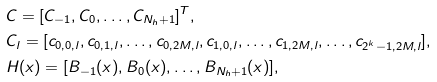<formula> <loc_0><loc_0><loc_500><loc_500>& C = [ C _ { - 1 } , C _ { 0 } , \dots , C _ { N _ { h } + 1 } ] ^ { T } , \\ & C _ { l } = [ c _ { 0 , 0 , l } , c _ { 0 , 1 , l } , \dots , c _ { 0 , 2 M , l } , c _ { 1 , 0 , l } , \dots , c _ { 1 , 2 M , l } , \dots , c _ { 2 ^ { k } - 1 , 2 M , l } ] , \\ & H ( x ) = [ B _ { - 1 } ( x ) , B _ { 0 } ( x ) , \dots , B _ { N _ { h } + 1 } ( x ) ] , \\</formula> 